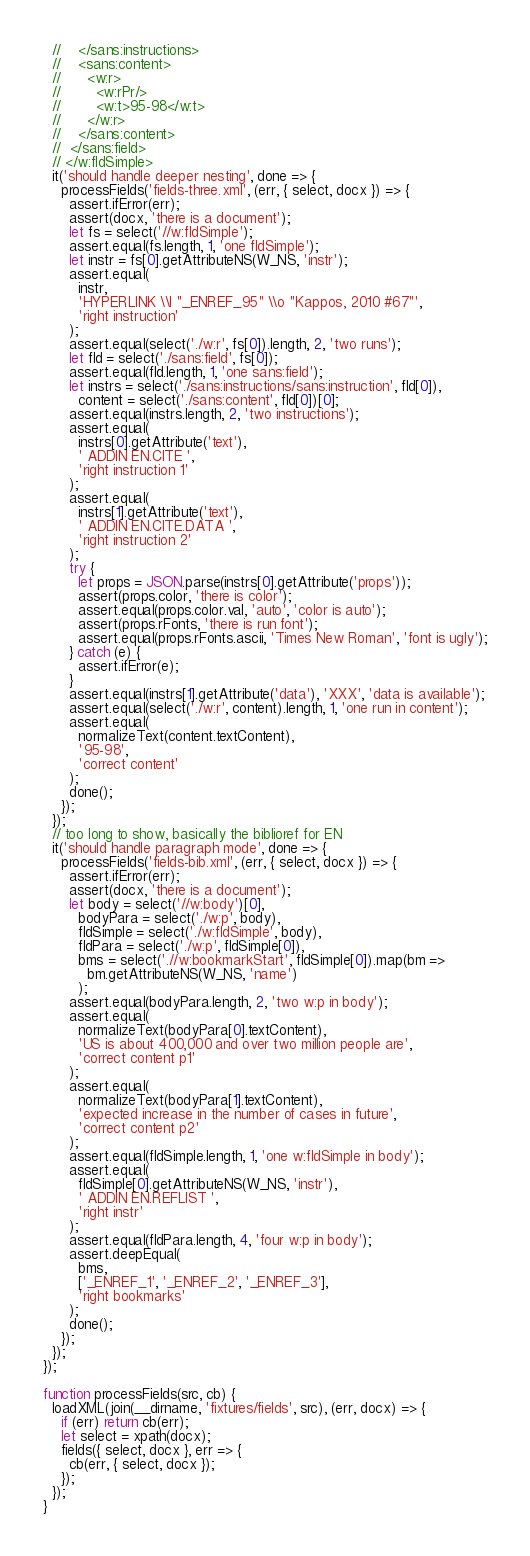Convert code to text. <code><loc_0><loc_0><loc_500><loc_500><_JavaScript_>  //    </sans:instructions>
  //    <sans:content>
  //      <w:r>
  //        <w:rPr/>
  //        <w:t>95-98</w:t>
  //      </w:r>
  //    </sans:content>
  //  </sans:field>
  // </w:fldSimple>
  it('should handle deeper nesting', done => {
    processFields('fields-three.xml', (err, { select, docx }) => {
      assert.ifError(err);
      assert(docx, 'there is a document');
      let fs = select('//w:fldSimple');
      assert.equal(fs.length, 1, 'one fldSimple');
      let instr = fs[0].getAttributeNS(W_NS, 'instr');
      assert.equal(
        instr,
        'HYPERLINK \\l "_ENREF_95" \\o "Kappos, 2010 #67"',
        'right instruction'
      );
      assert.equal(select('./w:r', fs[0]).length, 2, 'two runs');
      let fld = select('./sans:field', fs[0]);
      assert.equal(fld.length, 1, 'one sans:field');
      let instrs = select('./sans:instructions/sans:instruction', fld[0]),
        content = select('./sans:content', fld[0])[0];
      assert.equal(instrs.length, 2, 'two instructions');
      assert.equal(
        instrs[0].getAttribute('text'),
        ' ADDIN EN.CITE ',
        'right instruction 1'
      );
      assert.equal(
        instrs[1].getAttribute('text'),
        ' ADDIN EN.CITE.DATA ',
        'right instruction 2'
      );
      try {
        let props = JSON.parse(instrs[0].getAttribute('props'));
        assert(props.color, 'there is color');
        assert.equal(props.color.val, 'auto', 'color is auto');
        assert(props.rFonts, 'there is run font');
        assert.equal(props.rFonts.ascii, 'Times New Roman', 'font is ugly');
      } catch (e) {
        assert.ifError(e);
      }
      assert.equal(instrs[1].getAttribute('data'), 'XXX', 'data is available');
      assert.equal(select('./w:r', content).length, 1, 'one run in content');
      assert.equal(
        normalizeText(content.textContent),
        '95-98',
        'correct content'
      );
      done();
    });
  });
  // too long to show, basically the biblioref for EN
  it('should handle paragraph mode', done => {
    processFields('fields-bib.xml', (err, { select, docx }) => {
      assert.ifError(err);
      assert(docx, 'there is a document');
      let body = select('//w:body')[0],
        bodyPara = select('./w:p', body),
        fldSimple = select('./w:fldSimple', body),
        fldPara = select('./w:p', fldSimple[0]),
        bms = select('.//w:bookmarkStart', fldSimple[0]).map(bm =>
          bm.getAttributeNS(W_NS, 'name')
        );
      assert.equal(bodyPara.length, 2, 'two w:p in body');
      assert.equal(
        normalizeText(bodyPara[0].textContent),
        'US is about 400,000 and over two million people are',
        'correct content p1'
      );
      assert.equal(
        normalizeText(bodyPara[1].textContent),
        'expected increase in the number of cases in future',
        'correct content p2'
      );
      assert.equal(fldSimple.length, 1, 'one w:fldSimple in body');
      assert.equal(
        fldSimple[0].getAttributeNS(W_NS, 'instr'),
        ' ADDIN EN.REFLIST ',
        'right instr'
      );
      assert.equal(fldPara.length, 4, 'four w:p in body');
      assert.deepEqual(
        bms,
        ['_ENREF_1', '_ENREF_2', '_ENREF_3'],
        'right bookmarks'
      );
      done();
    });
  });
});

function processFields(src, cb) {
  loadXML(join(__dirname, 'fixtures/fields', src), (err, docx) => {
    if (err) return cb(err);
    let select = xpath(docx);
    fields({ select, docx }, err => {
      cb(err, { select, docx });
    });
  });
}
</code> 